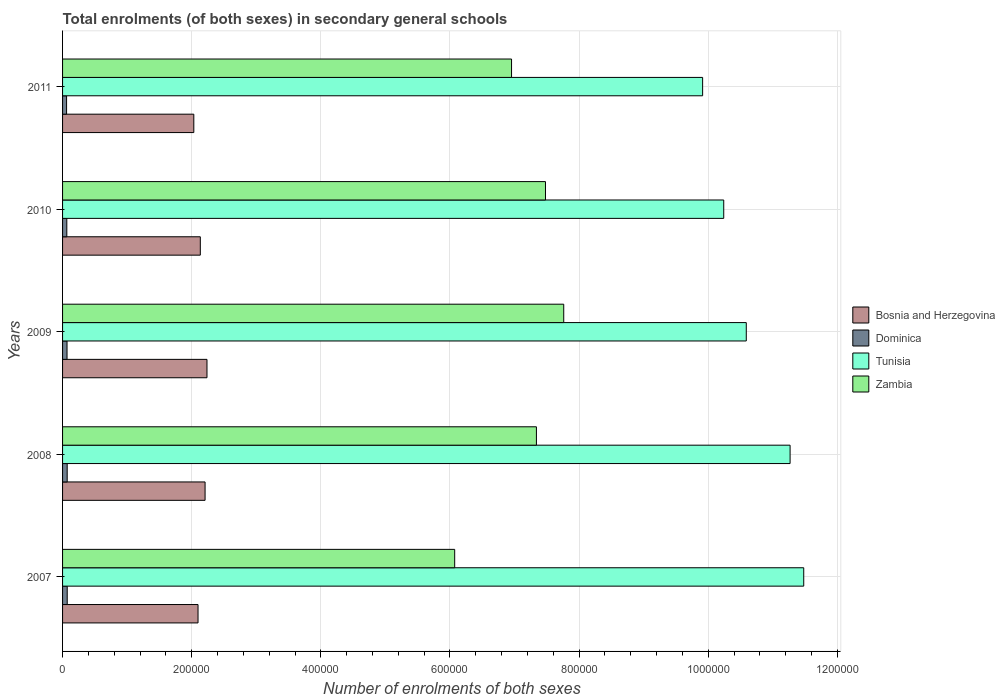How many groups of bars are there?
Give a very brief answer. 5. Are the number of bars on each tick of the Y-axis equal?
Your response must be concise. Yes. How many bars are there on the 2nd tick from the bottom?
Give a very brief answer. 4. What is the label of the 1st group of bars from the top?
Offer a terse response. 2011. In how many cases, is the number of bars for a given year not equal to the number of legend labels?
Provide a succinct answer. 0. What is the number of enrolments in secondary schools in Bosnia and Herzegovina in 2010?
Your answer should be very brief. 2.13e+05. Across all years, what is the maximum number of enrolments in secondary schools in Dominica?
Provide a short and direct response. 7213. Across all years, what is the minimum number of enrolments in secondary schools in Zambia?
Your answer should be compact. 6.07e+05. In which year was the number of enrolments in secondary schools in Dominica maximum?
Your answer should be compact. 2007. What is the total number of enrolments in secondary schools in Bosnia and Herzegovina in the graph?
Ensure brevity in your answer.  1.07e+06. What is the difference between the number of enrolments in secondary schools in Bosnia and Herzegovina in 2009 and that in 2010?
Provide a succinct answer. 1.03e+04. What is the difference between the number of enrolments in secondary schools in Bosnia and Herzegovina in 2009 and the number of enrolments in secondary schools in Dominica in 2008?
Offer a terse response. 2.17e+05. What is the average number of enrolments in secondary schools in Zambia per year?
Provide a short and direct response. 7.12e+05. In the year 2007, what is the difference between the number of enrolments in secondary schools in Zambia and number of enrolments in secondary schools in Tunisia?
Offer a very short reply. -5.41e+05. What is the ratio of the number of enrolments in secondary schools in Bosnia and Herzegovina in 2009 to that in 2010?
Your response must be concise. 1.05. Is the difference between the number of enrolments in secondary schools in Zambia in 2007 and 2009 greater than the difference between the number of enrolments in secondary schools in Tunisia in 2007 and 2009?
Ensure brevity in your answer.  No. What is the difference between the highest and the lowest number of enrolments in secondary schools in Tunisia?
Your answer should be compact. 1.57e+05. Is it the case that in every year, the sum of the number of enrolments in secondary schools in Dominica and number of enrolments in secondary schools in Tunisia is greater than the sum of number of enrolments in secondary schools in Bosnia and Herzegovina and number of enrolments in secondary schools in Zambia?
Offer a very short reply. No. What does the 1st bar from the top in 2007 represents?
Offer a terse response. Zambia. What does the 4th bar from the bottom in 2007 represents?
Ensure brevity in your answer.  Zambia. Is it the case that in every year, the sum of the number of enrolments in secondary schools in Tunisia and number of enrolments in secondary schools in Bosnia and Herzegovina is greater than the number of enrolments in secondary schools in Zambia?
Offer a terse response. Yes. Are all the bars in the graph horizontal?
Ensure brevity in your answer.  Yes. How many years are there in the graph?
Keep it short and to the point. 5. What is the difference between two consecutive major ticks on the X-axis?
Ensure brevity in your answer.  2.00e+05. Where does the legend appear in the graph?
Your answer should be very brief. Center right. How many legend labels are there?
Offer a very short reply. 4. What is the title of the graph?
Make the answer very short. Total enrolments (of both sexes) in secondary general schools. What is the label or title of the X-axis?
Provide a succinct answer. Number of enrolments of both sexes. What is the Number of enrolments of both sexes in Bosnia and Herzegovina in 2007?
Make the answer very short. 2.10e+05. What is the Number of enrolments of both sexes in Dominica in 2007?
Make the answer very short. 7213. What is the Number of enrolments of both sexes of Tunisia in 2007?
Provide a short and direct response. 1.15e+06. What is the Number of enrolments of both sexes in Zambia in 2007?
Offer a very short reply. 6.07e+05. What is the Number of enrolments of both sexes of Bosnia and Herzegovina in 2008?
Offer a terse response. 2.21e+05. What is the Number of enrolments of both sexes of Dominica in 2008?
Make the answer very short. 7162. What is the Number of enrolments of both sexes of Tunisia in 2008?
Give a very brief answer. 1.13e+06. What is the Number of enrolments of both sexes of Zambia in 2008?
Ensure brevity in your answer.  7.34e+05. What is the Number of enrolments of both sexes of Bosnia and Herzegovina in 2009?
Offer a terse response. 2.24e+05. What is the Number of enrolments of both sexes of Dominica in 2009?
Keep it short and to the point. 6926. What is the Number of enrolments of both sexes of Tunisia in 2009?
Your response must be concise. 1.06e+06. What is the Number of enrolments of both sexes of Zambia in 2009?
Keep it short and to the point. 7.76e+05. What is the Number of enrolments of both sexes in Bosnia and Herzegovina in 2010?
Your answer should be very brief. 2.13e+05. What is the Number of enrolments of both sexes in Dominica in 2010?
Offer a terse response. 6581. What is the Number of enrolments of both sexes of Tunisia in 2010?
Give a very brief answer. 1.02e+06. What is the Number of enrolments of both sexes in Zambia in 2010?
Your response must be concise. 7.48e+05. What is the Number of enrolments of both sexes of Bosnia and Herzegovina in 2011?
Ensure brevity in your answer.  2.03e+05. What is the Number of enrolments of both sexes in Dominica in 2011?
Your answer should be compact. 6205. What is the Number of enrolments of both sexes of Tunisia in 2011?
Provide a short and direct response. 9.91e+05. What is the Number of enrolments of both sexes in Zambia in 2011?
Your answer should be compact. 6.95e+05. Across all years, what is the maximum Number of enrolments of both sexes of Bosnia and Herzegovina?
Keep it short and to the point. 2.24e+05. Across all years, what is the maximum Number of enrolments of both sexes in Dominica?
Your answer should be compact. 7213. Across all years, what is the maximum Number of enrolments of both sexes in Tunisia?
Provide a succinct answer. 1.15e+06. Across all years, what is the maximum Number of enrolments of both sexes of Zambia?
Your response must be concise. 7.76e+05. Across all years, what is the minimum Number of enrolments of both sexes in Bosnia and Herzegovina?
Offer a very short reply. 2.03e+05. Across all years, what is the minimum Number of enrolments of both sexes of Dominica?
Your response must be concise. 6205. Across all years, what is the minimum Number of enrolments of both sexes in Tunisia?
Offer a very short reply. 9.91e+05. Across all years, what is the minimum Number of enrolments of both sexes in Zambia?
Make the answer very short. 6.07e+05. What is the total Number of enrolments of both sexes of Bosnia and Herzegovina in the graph?
Make the answer very short. 1.07e+06. What is the total Number of enrolments of both sexes in Dominica in the graph?
Your response must be concise. 3.41e+04. What is the total Number of enrolments of both sexes in Tunisia in the graph?
Keep it short and to the point. 5.35e+06. What is the total Number of enrolments of both sexes of Zambia in the graph?
Give a very brief answer. 3.56e+06. What is the difference between the Number of enrolments of both sexes in Bosnia and Herzegovina in 2007 and that in 2008?
Provide a succinct answer. -1.09e+04. What is the difference between the Number of enrolments of both sexes in Dominica in 2007 and that in 2008?
Make the answer very short. 51. What is the difference between the Number of enrolments of both sexes in Tunisia in 2007 and that in 2008?
Provide a short and direct response. 2.11e+04. What is the difference between the Number of enrolments of both sexes in Zambia in 2007 and that in 2008?
Your answer should be very brief. -1.27e+05. What is the difference between the Number of enrolments of both sexes of Bosnia and Herzegovina in 2007 and that in 2009?
Provide a short and direct response. -1.39e+04. What is the difference between the Number of enrolments of both sexes of Dominica in 2007 and that in 2009?
Offer a terse response. 287. What is the difference between the Number of enrolments of both sexes in Tunisia in 2007 and that in 2009?
Offer a terse response. 8.90e+04. What is the difference between the Number of enrolments of both sexes in Zambia in 2007 and that in 2009?
Give a very brief answer. -1.69e+05. What is the difference between the Number of enrolments of both sexes in Bosnia and Herzegovina in 2007 and that in 2010?
Give a very brief answer. -3533. What is the difference between the Number of enrolments of both sexes of Dominica in 2007 and that in 2010?
Provide a short and direct response. 632. What is the difference between the Number of enrolments of both sexes in Tunisia in 2007 and that in 2010?
Your response must be concise. 1.24e+05. What is the difference between the Number of enrolments of both sexes of Zambia in 2007 and that in 2010?
Provide a short and direct response. -1.41e+05. What is the difference between the Number of enrolments of both sexes in Bosnia and Herzegovina in 2007 and that in 2011?
Keep it short and to the point. 6530. What is the difference between the Number of enrolments of both sexes of Dominica in 2007 and that in 2011?
Your answer should be very brief. 1008. What is the difference between the Number of enrolments of both sexes of Tunisia in 2007 and that in 2011?
Give a very brief answer. 1.57e+05. What is the difference between the Number of enrolments of both sexes in Zambia in 2007 and that in 2011?
Offer a very short reply. -8.81e+04. What is the difference between the Number of enrolments of both sexes in Bosnia and Herzegovina in 2008 and that in 2009?
Provide a short and direct response. -2965. What is the difference between the Number of enrolments of both sexes in Dominica in 2008 and that in 2009?
Your response must be concise. 236. What is the difference between the Number of enrolments of both sexes of Tunisia in 2008 and that in 2009?
Your answer should be very brief. 6.79e+04. What is the difference between the Number of enrolments of both sexes in Zambia in 2008 and that in 2009?
Ensure brevity in your answer.  -4.23e+04. What is the difference between the Number of enrolments of both sexes of Bosnia and Herzegovina in 2008 and that in 2010?
Offer a very short reply. 7367. What is the difference between the Number of enrolments of both sexes of Dominica in 2008 and that in 2010?
Give a very brief answer. 581. What is the difference between the Number of enrolments of both sexes of Tunisia in 2008 and that in 2010?
Ensure brevity in your answer.  1.03e+05. What is the difference between the Number of enrolments of both sexes in Zambia in 2008 and that in 2010?
Ensure brevity in your answer.  -1.41e+04. What is the difference between the Number of enrolments of both sexes in Bosnia and Herzegovina in 2008 and that in 2011?
Keep it short and to the point. 1.74e+04. What is the difference between the Number of enrolments of both sexes of Dominica in 2008 and that in 2011?
Provide a succinct answer. 957. What is the difference between the Number of enrolments of both sexes of Tunisia in 2008 and that in 2011?
Provide a succinct answer. 1.35e+05. What is the difference between the Number of enrolments of both sexes of Zambia in 2008 and that in 2011?
Give a very brief answer. 3.85e+04. What is the difference between the Number of enrolments of both sexes of Bosnia and Herzegovina in 2009 and that in 2010?
Provide a short and direct response. 1.03e+04. What is the difference between the Number of enrolments of both sexes of Dominica in 2009 and that in 2010?
Ensure brevity in your answer.  345. What is the difference between the Number of enrolments of both sexes of Tunisia in 2009 and that in 2010?
Ensure brevity in your answer.  3.49e+04. What is the difference between the Number of enrolments of both sexes of Zambia in 2009 and that in 2010?
Offer a very short reply. 2.83e+04. What is the difference between the Number of enrolments of both sexes in Bosnia and Herzegovina in 2009 and that in 2011?
Offer a terse response. 2.04e+04. What is the difference between the Number of enrolments of both sexes of Dominica in 2009 and that in 2011?
Offer a very short reply. 721. What is the difference between the Number of enrolments of both sexes of Tunisia in 2009 and that in 2011?
Provide a short and direct response. 6.76e+04. What is the difference between the Number of enrolments of both sexes of Zambia in 2009 and that in 2011?
Your answer should be compact. 8.08e+04. What is the difference between the Number of enrolments of both sexes in Bosnia and Herzegovina in 2010 and that in 2011?
Your answer should be compact. 1.01e+04. What is the difference between the Number of enrolments of both sexes in Dominica in 2010 and that in 2011?
Your answer should be very brief. 376. What is the difference between the Number of enrolments of both sexes in Tunisia in 2010 and that in 2011?
Provide a succinct answer. 3.27e+04. What is the difference between the Number of enrolments of both sexes in Zambia in 2010 and that in 2011?
Offer a very short reply. 5.26e+04. What is the difference between the Number of enrolments of both sexes of Bosnia and Herzegovina in 2007 and the Number of enrolments of both sexes of Dominica in 2008?
Provide a short and direct response. 2.03e+05. What is the difference between the Number of enrolments of both sexes of Bosnia and Herzegovina in 2007 and the Number of enrolments of both sexes of Tunisia in 2008?
Keep it short and to the point. -9.17e+05. What is the difference between the Number of enrolments of both sexes of Bosnia and Herzegovina in 2007 and the Number of enrolments of both sexes of Zambia in 2008?
Give a very brief answer. -5.24e+05. What is the difference between the Number of enrolments of both sexes in Dominica in 2007 and the Number of enrolments of both sexes in Tunisia in 2008?
Provide a short and direct response. -1.12e+06. What is the difference between the Number of enrolments of both sexes in Dominica in 2007 and the Number of enrolments of both sexes in Zambia in 2008?
Make the answer very short. -7.27e+05. What is the difference between the Number of enrolments of both sexes in Tunisia in 2007 and the Number of enrolments of both sexes in Zambia in 2008?
Provide a short and direct response. 4.14e+05. What is the difference between the Number of enrolments of both sexes in Bosnia and Herzegovina in 2007 and the Number of enrolments of both sexes in Dominica in 2009?
Provide a short and direct response. 2.03e+05. What is the difference between the Number of enrolments of both sexes in Bosnia and Herzegovina in 2007 and the Number of enrolments of both sexes in Tunisia in 2009?
Give a very brief answer. -8.49e+05. What is the difference between the Number of enrolments of both sexes in Bosnia and Herzegovina in 2007 and the Number of enrolments of both sexes in Zambia in 2009?
Offer a terse response. -5.66e+05. What is the difference between the Number of enrolments of both sexes of Dominica in 2007 and the Number of enrolments of both sexes of Tunisia in 2009?
Ensure brevity in your answer.  -1.05e+06. What is the difference between the Number of enrolments of both sexes in Dominica in 2007 and the Number of enrolments of both sexes in Zambia in 2009?
Your answer should be very brief. -7.69e+05. What is the difference between the Number of enrolments of both sexes in Tunisia in 2007 and the Number of enrolments of both sexes in Zambia in 2009?
Ensure brevity in your answer.  3.72e+05. What is the difference between the Number of enrolments of both sexes in Bosnia and Herzegovina in 2007 and the Number of enrolments of both sexes in Dominica in 2010?
Offer a very short reply. 2.03e+05. What is the difference between the Number of enrolments of both sexes of Bosnia and Herzegovina in 2007 and the Number of enrolments of both sexes of Tunisia in 2010?
Your answer should be compact. -8.14e+05. What is the difference between the Number of enrolments of both sexes of Bosnia and Herzegovina in 2007 and the Number of enrolments of both sexes of Zambia in 2010?
Offer a very short reply. -5.38e+05. What is the difference between the Number of enrolments of both sexes of Dominica in 2007 and the Number of enrolments of both sexes of Tunisia in 2010?
Your answer should be compact. -1.02e+06. What is the difference between the Number of enrolments of both sexes in Dominica in 2007 and the Number of enrolments of both sexes in Zambia in 2010?
Make the answer very short. -7.41e+05. What is the difference between the Number of enrolments of both sexes in Tunisia in 2007 and the Number of enrolments of both sexes in Zambia in 2010?
Ensure brevity in your answer.  4.00e+05. What is the difference between the Number of enrolments of both sexes in Bosnia and Herzegovina in 2007 and the Number of enrolments of both sexes in Dominica in 2011?
Your response must be concise. 2.04e+05. What is the difference between the Number of enrolments of both sexes of Bosnia and Herzegovina in 2007 and the Number of enrolments of both sexes of Tunisia in 2011?
Keep it short and to the point. -7.82e+05. What is the difference between the Number of enrolments of both sexes in Bosnia and Herzegovina in 2007 and the Number of enrolments of both sexes in Zambia in 2011?
Your answer should be compact. -4.86e+05. What is the difference between the Number of enrolments of both sexes in Dominica in 2007 and the Number of enrolments of both sexes in Tunisia in 2011?
Your response must be concise. -9.84e+05. What is the difference between the Number of enrolments of both sexes in Dominica in 2007 and the Number of enrolments of both sexes in Zambia in 2011?
Ensure brevity in your answer.  -6.88e+05. What is the difference between the Number of enrolments of both sexes of Tunisia in 2007 and the Number of enrolments of both sexes of Zambia in 2011?
Keep it short and to the point. 4.53e+05. What is the difference between the Number of enrolments of both sexes of Bosnia and Herzegovina in 2008 and the Number of enrolments of both sexes of Dominica in 2009?
Your answer should be compact. 2.14e+05. What is the difference between the Number of enrolments of both sexes of Bosnia and Herzegovina in 2008 and the Number of enrolments of both sexes of Tunisia in 2009?
Your response must be concise. -8.38e+05. What is the difference between the Number of enrolments of both sexes in Bosnia and Herzegovina in 2008 and the Number of enrolments of both sexes in Zambia in 2009?
Ensure brevity in your answer.  -5.55e+05. What is the difference between the Number of enrolments of both sexes of Dominica in 2008 and the Number of enrolments of both sexes of Tunisia in 2009?
Ensure brevity in your answer.  -1.05e+06. What is the difference between the Number of enrolments of both sexes in Dominica in 2008 and the Number of enrolments of both sexes in Zambia in 2009?
Your answer should be compact. -7.69e+05. What is the difference between the Number of enrolments of both sexes of Tunisia in 2008 and the Number of enrolments of both sexes of Zambia in 2009?
Your answer should be compact. 3.51e+05. What is the difference between the Number of enrolments of both sexes in Bosnia and Herzegovina in 2008 and the Number of enrolments of both sexes in Dominica in 2010?
Provide a short and direct response. 2.14e+05. What is the difference between the Number of enrolments of both sexes of Bosnia and Herzegovina in 2008 and the Number of enrolments of both sexes of Tunisia in 2010?
Give a very brief answer. -8.03e+05. What is the difference between the Number of enrolments of both sexes in Bosnia and Herzegovina in 2008 and the Number of enrolments of both sexes in Zambia in 2010?
Ensure brevity in your answer.  -5.27e+05. What is the difference between the Number of enrolments of both sexes in Dominica in 2008 and the Number of enrolments of both sexes in Tunisia in 2010?
Make the answer very short. -1.02e+06. What is the difference between the Number of enrolments of both sexes in Dominica in 2008 and the Number of enrolments of both sexes in Zambia in 2010?
Give a very brief answer. -7.41e+05. What is the difference between the Number of enrolments of both sexes in Tunisia in 2008 and the Number of enrolments of both sexes in Zambia in 2010?
Offer a terse response. 3.79e+05. What is the difference between the Number of enrolments of both sexes of Bosnia and Herzegovina in 2008 and the Number of enrolments of both sexes of Dominica in 2011?
Offer a terse response. 2.15e+05. What is the difference between the Number of enrolments of both sexes of Bosnia and Herzegovina in 2008 and the Number of enrolments of both sexes of Tunisia in 2011?
Your response must be concise. -7.71e+05. What is the difference between the Number of enrolments of both sexes of Bosnia and Herzegovina in 2008 and the Number of enrolments of both sexes of Zambia in 2011?
Provide a short and direct response. -4.75e+05. What is the difference between the Number of enrolments of both sexes in Dominica in 2008 and the Number of enrolments of both sexes in Tunisia in 2011?
Your answer should be compact. -9.84e+05. What is the difference between the Number of enrolments of both sexes of Dominica in 2008 and the Number of enrolments of both sexes of Zambia in 2011?
Make the answer very short. -6.88e+05. What is the difference between the Number of enrolments of both sexes of Tunisia in 2008 and the Number of enrolments of both sexes of Zambia in 2011?
Keep it short and to the point. 4.31e+05. What is the difference between the Number of enrolments of both sexes in Bosnia and Herzegovina in 2009 and the Number of enrolments of both sexes in Dominica in 2010?
Your answer should be very brief. 2.17e+05. What is the difference between the Number of enrolments of both sexes in Bosnia and Herzegovina in 2009 and the Number of enrolments of both sexes in Tunisia in 2010?
Give a very brief answer. -8.00e+05. What is the difference between the Number of enrolments of both sexes in Bosnia and Herzegovina in 2009 and the Number of enrolments of both sexes in Zambia in 2010?
Your answer should be very brief. -5.24e+05. What is the difference between the Number of enrolments of both sexes of Dominica in 2009 and the Number of enrolments of both sexes of Tunisia in 2010?
Give a very brief answer. -1.02e+06. What is the difference between the Number of enrolments of both sexes of Dominica in 2009 and the Number of enrolments of both sexes of Zambia in 2010?
Ensure brevity in your answer.  -7.41e+05. What is the difference between the Number of enrolments of both sexes in Tunisia in 2009 and the Number of enrolments of both sexes in Zambia in 2010?
Provide a short and direct response. 3.11e+05. What is the difference between the Number of enrolments of both sexes in Bosnia and Herzegovina in 2009 and the Number of enrolments of both sexes in Dominica in 2011?
Provide a short and direct response. 2.17e+05. What is the difference between the Number of enrolments of both sexes in Bosnia and Herzegovina in 2009 and the Number of enrolments of both sexes in Tunisia in 2011?
Provide a succinct answer. -7.68e+05. What is the difference between the Number of enrolments of both sexes in Bosnia and Herzegovina in 2009 and the Number of enrolments of both sexes in Zambia in 2011?
Provide a short and direct response. -4.72e+05. What is the difference between the Number of enrolments of both sexes of Dominica in 2009 and the Number of enrolments of both sexes of Tunisia in 2011?
Make the answer very short. -9.84e+05. What is the difference between the Number of enrolments of both sexes in Dominica in 2009 and the Number of enrolments of both sexes in Zambia in 2011?
Your answer should be very brief. -6.88e+05. What is the difference between the Number of enrolments of both sexes in Tunisia in 2009 and the Number of enrolments of both sexes in Zambia in 2011?
Provide a succinct answer. 3.64e+05. What is the difference between the Number of enrolments of both sexes in Bosnia and Herzegovina in 2010 and the Number of enrolments of both sexes in Dominica in 2011?
Give a very brief answer. 2.07e+05. What is the difference between the Number of enrolments of both sexes of Bosnia and Herzegovina in 2010 and the Number of enrolments of both sexes of Tunisia in 2011?
Offer a very short reply. -7.78e+05. What is the difference between the Number of enrolments of both sexes in Bosnia and Herzegovina in 2010 and the Number of enrolments of both sexes in Zambia in 2011?
Your response must be concise. -4.82e+05. What is the difference between the Number of enrolments of both sexes of Dominica in 2010 and the Number of enrolments of both sexes of Tunisia in 2011?
Your answer should be very brief. -9.85e+05. What is the difference between the Number of enrolments of both sexes of Dominica in 2010 and the Number of enrolments of both sexes of Zambia in 2011?
Your response must be concise. -6.89e+05. What is the difference between the Number of enrolments of both sexes in Tunisia in 2010 and the Number of enrolments of both sexes in Zambia in 2011?
Your response must be concise. 3.29e+05. What is the average Number of enrolments of both sexes of Bosnia and Herzegovina per year?
Keep it short and to the point. 2.14e+05. What is the average Number of enrolments of both sexes of Dominica per year?
Offer a terse response. 6817.4. What is the average Number of enrolments of both sexes in Tunisia per year?
Keep it short and to the point. 1.07e+06. What is the average Number of enrolments of both sexes in Zambia per year?
Give a very brief answer. 7.12e+05. In the year 2007, what is the difference between the Number of enrolments of both sexes in Bosnia and Herzegovina and Number of enrolments of both sexes in Dominica?
Offer a very short reply. 2.03e+05. In the year 2007, what is the difference between the Number of enrolments of both sexes in Bosnia and Herzegovina and Number of enrolments of both sexes in Tunisia?
Ensure brevity in your answer.  -9.38e+05. In the year 2007, what is the difference between the Number of enrolments of both sexes in Bosnia and Herzegovina and Number of enrolments of both sexes in Zambia?
Give a very brief answer. -3.97e+05. In the year 2007, what is the difference between the Number of enrolments of both sexes of Dominica and Number of enrolments of both sexes of Tunisia?
Provide a succinct answer. -1.14e+06. In the year 2007, what is the difference between the Number of enrolments of both sexes in Dominica and Number of enrolments of both sexes in Zambia?
Your answer should be compact. -6.00e+05. In the year 2007, what is the difference between the Number of enrolments of both sexes in Tunisia and Number of enrolments of both sexes in Zambia?
Offer a very short reply. 5.41e+05. In the year 2008, what is the difference between the Number of enrolments of both sexes in Bosnia and Herzegovina and Number of enrolments of both sexes in Dominica?
Your response must be concise. 2.14e+05. In the year 2008, what is the difference between the Number of enrolments of both sexes in Bosnia and Herzegovina and Number of enrolments of both sexes in Tunisia?
Make the answer very short. -9.06e+05. In the year 2008, what is the difference between the Number of enrolments of both sexes of Bosnia and Herzegovina and Number of enrolments of both sexes of Zambia?
Your answer should be very brief. -5.13e+05. In the year 2008, what is the difference between the Number of enrolments of both sexes in Dominica and Number of enrolments of both sexes in Tunisia?
Provide a short and direct response. -1.12e+06. In the year 2008, what is the difference between the Number of enrolments of both sexes in Dominica and Number of enrolments of both sexes in Zambia?
Make the answer very short. -7.27e+05. In the year 2008, what is the difference between the Number of enrolments of both sexes in Tunisia and Number of enrolments of both sexes in Zambia?
Keep it short and to the point. 3.93e+05. In the year 2009, what is the difference between the Number of enrolments of both sexes in Bosnia and Herzegovina and Number of enrolments of both sexes in Dominica?
Offer a very short reply. 2.17e+05. In the year 2009, what is the difference between the Number of enrolments of both sexes in Bosnia and Herzegovina and Number of enrolments of both sexes in Tunisia?
Keep it short and to the point. -8.35e+05. In the year 2009, what is the difference between the Number of enrolments of both sexes in Bosnia and Herzegovina and Number of enrolments of both sexes in Zambia?
Your response must be concise. -5.53e+05. In the year 2009, what is the difference between the Number of enrolments of both sexes in Dominica and Number of enrolments of both sexes in Tunisia?
Ensure brevity in your answer.  -1.05e+06. In the year 2009, what is the difference between the Number of enrolments of both sexes of Dominica and Number of enrolments of both sexes of Zambia?
Your response must be concise. -7.69e+05. In the year 2009, what is the difference between the Number of enrolments of both sexes of Tunisia and Number of enrolments of both sexes of Zambia?
Offer a very short reply. 2.83e+05. In the year 2010, what is the difference between the Number of enrolments of both sexes in Bosnia and Herzegovina and Number of enrolments of both sexes in Dominica?
Your answer should be compact. 2.07e+05. In the year 2010, what is the difference between the Number of enrolments of both sexes in Bosnia and Herzegovina and Number of enrolments of both sexes in Tunisia?
Keep it short and to the point. -8.11e+05. In the year 2010, what is the difference between the Number of enrolments of both sexes of Bosnia and Herzegovina and Number of enrolments of both sexes of Zambia?
Offer a terse response. -5.35e+05. In the year 2010, what is the difference between the Number of enrolments of both sexes in Dominica and Number of enrolments of both sexes in Tunisia?
Make the answer very short. -1.02e+06. In the year 2010, what is the difference between the Number of enrolments of both sexes in Dominica and Number of enrolments of both sexes in Zambia?
Offer a terse response. -7.41e+05. In the year 2010, what is the difference between the Number of enrolments of both sexes of Tunisia and Number of enrolments of both sexes of Zambia?
Provide a short and direct response. 2.76e+05. In the year 2011, what is the difference between the Number of enrolments of both sexes in Bosnia and Herzegovina and Number of enrolments of both sexes in Dominica?
Give a very brief answer. 1.97e+05. In the year 2011, what is the difference between the Number of enrolments of both sexes in Bosnia and Herzegovina and Number of enrolments of both sexes in Tunisia?
Keep it short and to the point. -7.88e+05. In the year 2011, what is the difference between the Number of enrolments of both sexes in Bosnia and Herzegovina and Number of enrolments of both sexes in Zambia?
Give a very brief answer. -4.92e+05. In the year 2011, what is the difference between the Number of enrolments of both sexes in Dominica and Number of enrolments of both sexes in Tunisia?
Provide a succinct answer. -9.85e+05. In the year 2011, what is the difference between the Number of enrolments of both sexes in Dominica and Number of enrolments of both sexes in Zambia?
Make the answer very short. -6.89e+05. In the year 2011, what is the difference between the Number of enrolments of both sexes in Tunisia and Number of enrolments of both sexes in Zambia?
Offer a very short reply. 2.96e+05. What is the ratio of the Number of enrolments of both sexes of Bosnia and Herzegovina in 2007 to that in 2008?
Make the answer very short. 0.95. What is the ratio of the Number of enrolments of both sexes of Dominica in 2007 to that in 2008?
Make the answer very short. 1.01. What is the ratio of the Number of enrolments of both sexes of Tunisia in 2007 to that in 2008?
Ensure brevity in your answer.  1.02. What is the ratio of the Number of enrolments of both sexes of Zambia in 2007 to that in 2008?
Your answer should be very brief. 0.83. What is the ratio of the Number of enrolments of both sexes in Bosnia and Herzegovina in 2007 to that in 2009?
Offer a terse response. 0.94. What is the ratio of the Number of enrolments of both sexes of Dominica in 2007 to that in 2009?
Ensure brevity in your answer.  1.04. What is the ratio of the Number of enrolments of both sexes in Tunisia in 2007 to that in 2009?
Ensure brevity in your answer.  1.08. What is the ratio of the Number of enrolments of both sexes of Zambia in 2007 to that in 2009?
Your answer should be very brief. 0.78. What is the ratio of the Number of enrolments of both sexes of Bosnia and Herzegovina in 2007 to that in 2010?
Provide a short and direct response. 0.98. What is the ratio of the Number of enrolments of both sexes in Dominica in 2007 to that in 2010?
Your answer should be very brief. 1.1. What is the ratio of the Number of enrolments of both sexes in Tunisia in 2007 to that in 2010?
Ensure brevity in your answer.  1.12. What is the ratio of the Number of enrolments of both sexes in Zambia in 2007 to that in 2010?
Your answer should be very brief. 0.81. What is the ratio of the Number of enrolments of both sexes of Bosnia and Herzegovina in 2007 to that in 2011?
Make the answer very short. 1.03. What is the ratio of the Number of enrolments of both sexes of Dominica in 2007 to that in 2011?
Keep it short and to the point. 1.16. What is the ratio of the Number of enrolments of both sexes in Tunisia in 2007 to that in 2011?
Ensure brevity in your answer.  1.16. What is the ratio of the Number of enrolments of both sexes in Zambia in 2007 to that in 2011?
Make the answer very short. 0.87. What is the ratio of the Number of enrolments of both sexes of Bosnia and Herzegovina in 2008 to that in 2009?
Your answer should be very brief. 0.99. What is the ratio of the Number of enrolments of both sexes in Dominica in 2008 to that in 2009?
Your answer should be very brief. 1.03. What is the ratio of the Number of enrolments of both sexes of Tunisia in 2008 to that in 2009?
Make the answer very short. 1.06. What is the ratio of the Number of enrolments of both sexes in Zambia in 2008 to that in 2009?
Give a very brief answer. 0.95. What is the ratio of the Number of enrolments of both sexes of Bosnia and Herzegovina in 2008 to that in 2010?
Provide a short and direct response. 1.03. What is the ratio of the Number of enrolments of both sexes of Dominica in 2008 to that in 2010?
Provide a short and direct response. 1.09. What is the ratio of the Number of enrolments of both sexes in Tunisia in 2008 to that in 2010?
Give a very brief answer. 1.1. What is the ratio of the Number of enrolments of both sexes of Zambia in 2008 to that in 2010?
Your answer should be very brief. 0.98. What is the ratio of the Number of enrolments of both sexes of Bosnia and Herzegovina in 2008 to that in 2011?
Your answer should be compact. 1.09. What is the ratio of the Number of enrolments of both sexes of Dominica in 2008 to that in 2011?
Provide a short and direct response. 1.15. What is the ratio of the Number of enrolments of both sexes in Tunisia in 2008 to that in 2011?
Offer a terse response. 1.14. What is the ratio of the Number of enrolments of both sexes of Zambia in 2008 to that in 2011?
Offer a terse response. 1.06. What is the ratio of the Number of enrolments of both sexes in Bosnia and Herzegovina in 2009 to that in 2010?
Ensure brevity in your answer.  1.05. What is the ratio of the Number of enrolments of both sexes of Dominica in 2009 to that in 2010?
Offer a terse response. 1.05. What is the ratio of the Number of enrolments of both sexes in Tunisia in 2009 to that in 2010?
Offer a very short reply. 1.03. What is the ratio of the Number of enrolments of both sexes in Zambia in 2009 to that in 2010?
Provide a short and direct response. 1.04. What is the ratio of the Number of enrolments of both sexes in Bosnia and Herzegovina in 2009 to that in 2011?
Your answer should be compact. 1.1. What is the ratio of the Number of enrolments of both sexes of Dominica in 2009 to that in 2011?
Your answer should be compact. 1.12. What is the ratio of the Number of enrolments of both sexes of Tunisia in 2009 to that in 2011?
Make the answer very short. 1.07. What is the ratio of the Number of enrolments of both sexes of Zambia in 2009 to that in 2011?
Provide a short and direct response. 1.12. What is the ratio of the Number of enrolments of both sexes in Bosnia and Herzegovina in 2010 to that in 2011?
Your answer should be compact. 1.05. What is the ratio of the Number of enrolments of both sexes of Dominica in 2010 to that in 2011?
Provide a short and direct response. 1.06. What is the ratio of the Number of enrolments of both sexes in Tunisia in 2010 to that in 2011?
Keep it short and to the point. 1.03. What is the ratio of the Number of enrolments of both sexes in Zambia in 2010 to that in 2011?
Your answer should be compact. 1.08. What is the difference between the highest and the second highest Number of enrolments of both sexes of Bosnia and Herzegovina?
Provide a succinct answer. 2965. What is the difference between the highest and the second highest Number of enrolments of both sexes of Dominica?
Keep it short and to the point. 51. What is the difference between the highest and the second highest Number of enrolments of both sexes of Tunisia?
Ensure brevity in your answer.  2.11e+04. What is the difference between the highest and the second highest Number of enrolments of both sexes in Zambia?
Make the answer very short. 2.83e+04. What is the difference between the highest and the lowest Number of enrolments of both sexes of Bosnia and Herzegovina?
Make the answer very short. 2.04e+04. What is the difference between the highest and the lowest Number of enrolments of both sexes in Dominica?
Give a very brief answer. 1008. What is the difference between the highest and the lowest Number of enrolments of both sexes in Tunisia?
Offer a terse response. 1.57e+05. What is the difference between the highest and the lowest Number of enrolments of both sexes of Zambia?
Your answer should be compact. 1.69e+05. 